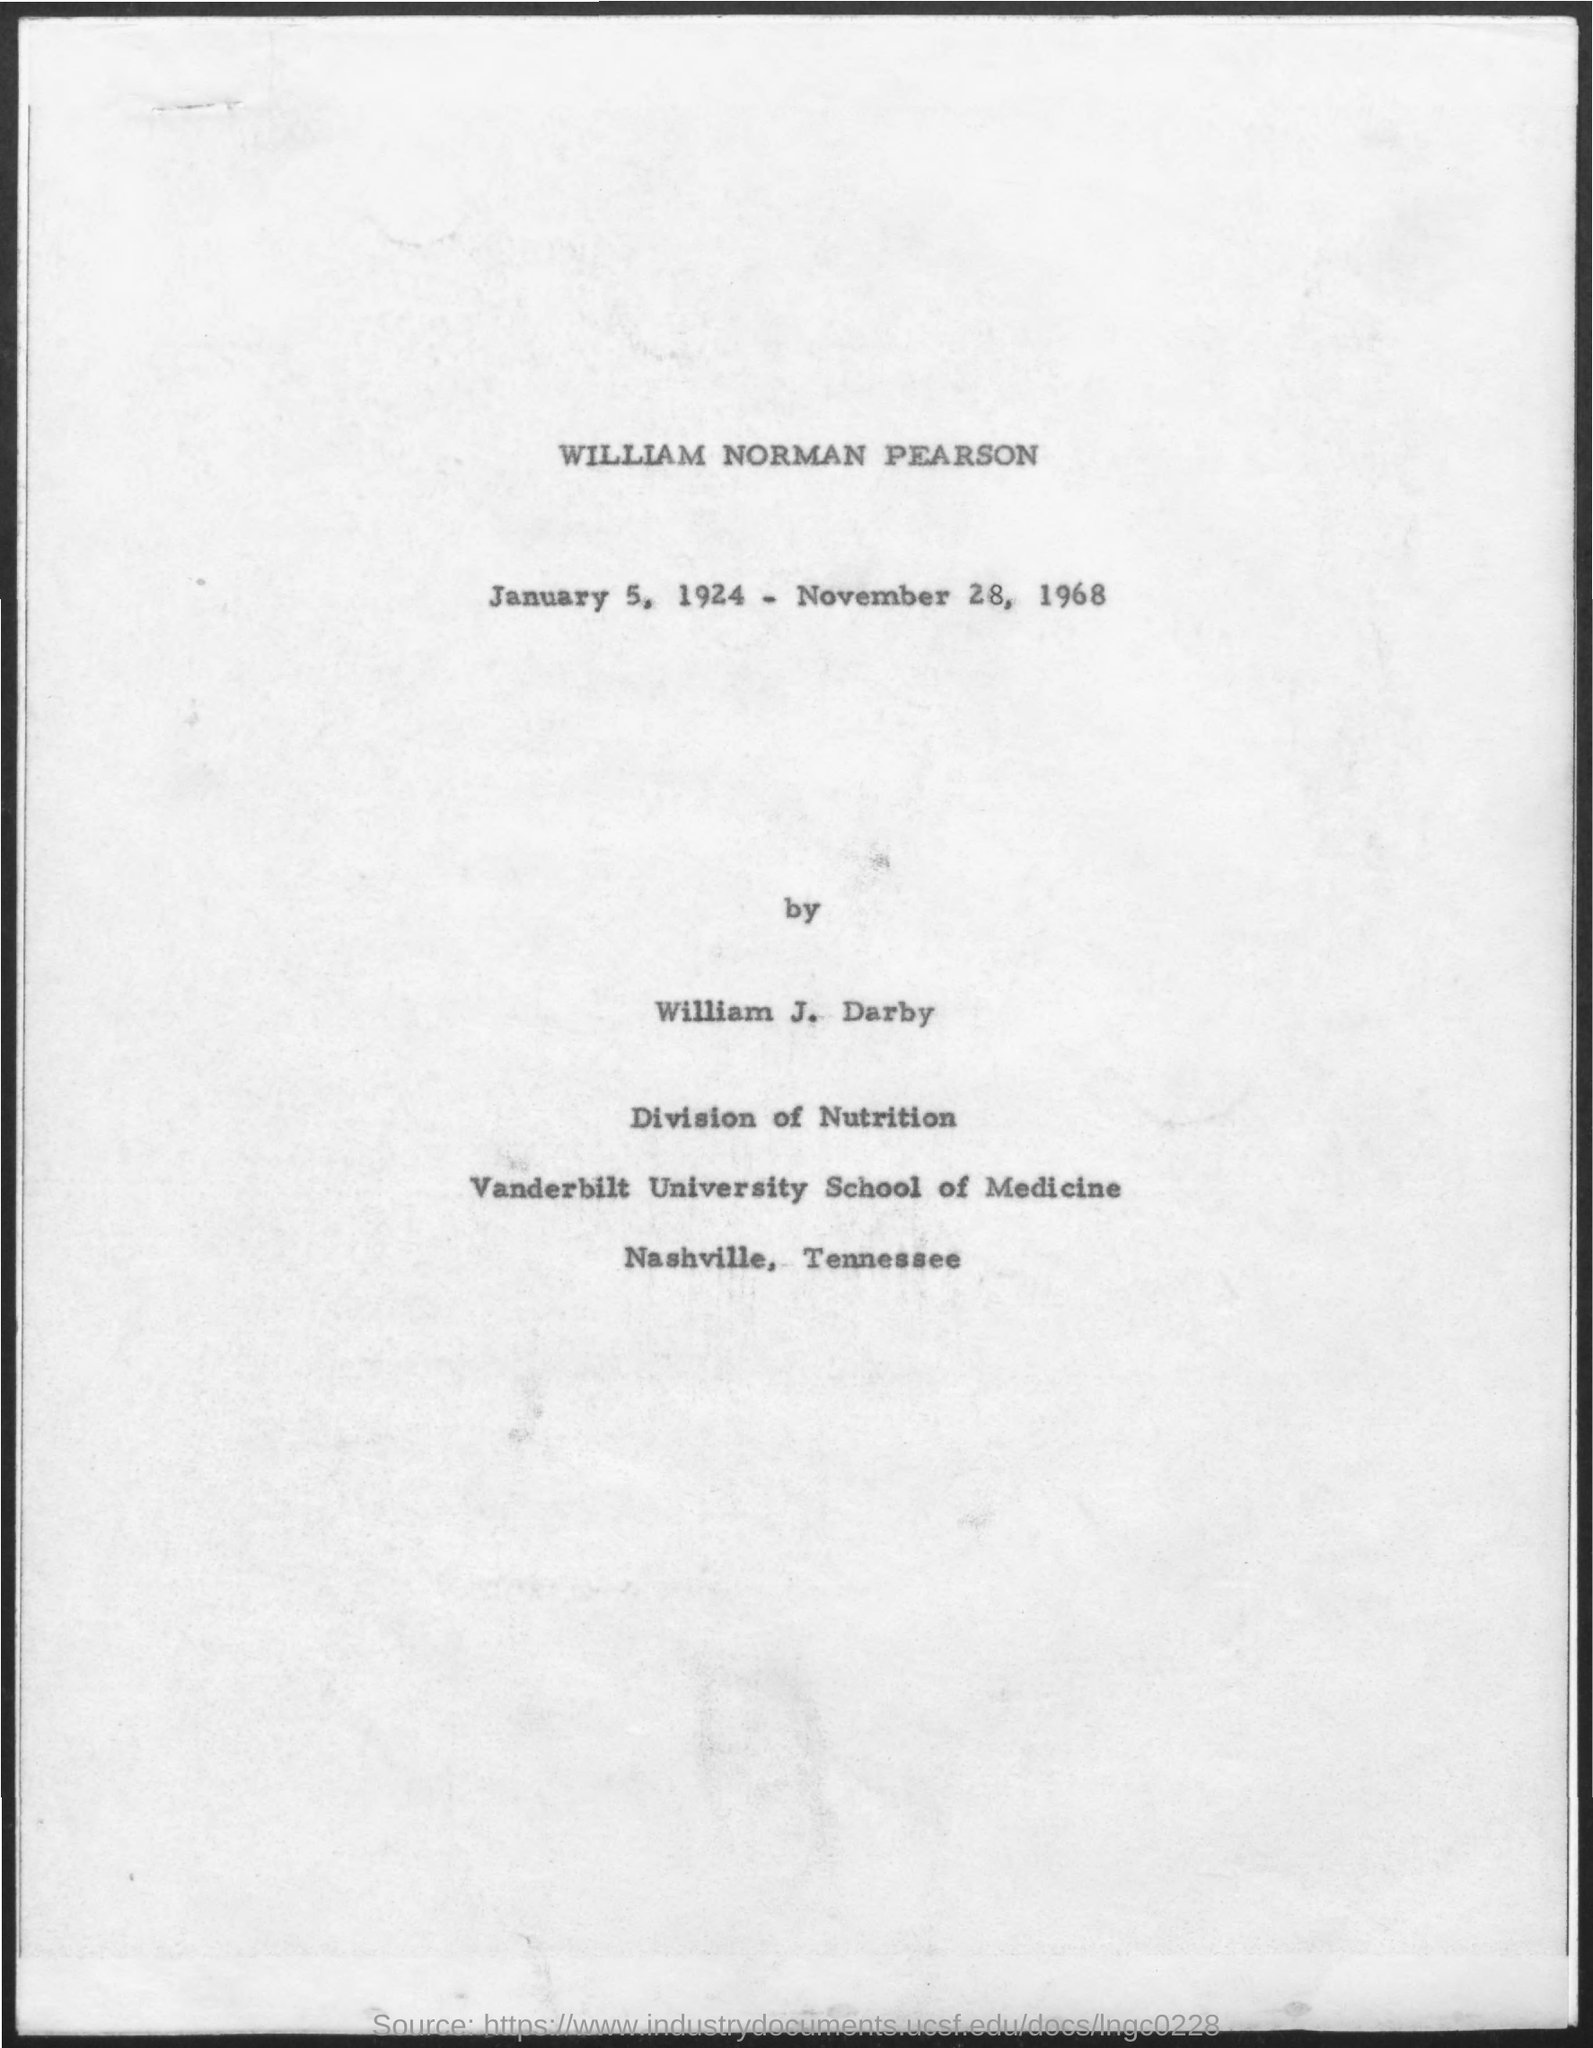What is the first title in the document?
Your response must be concise. William Norman Pearson. 